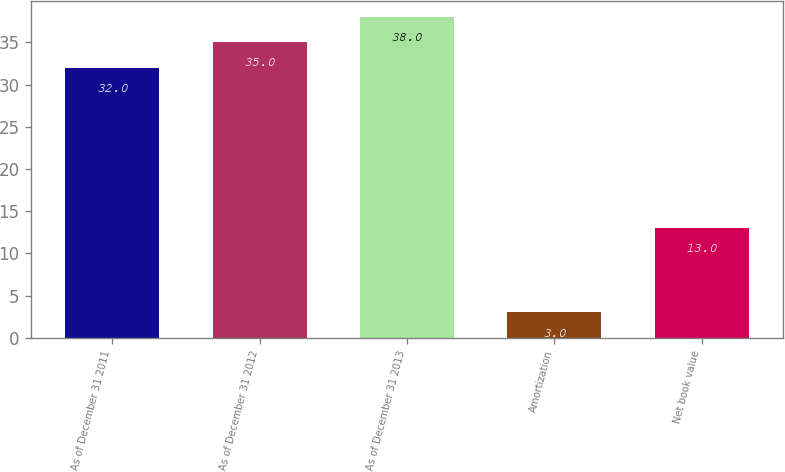Convert chart to OTSL. <chart><loc_0><loc_0><loc_500><loc_500><bar_chart><fcel>As of December 31 2011<fcel>As of December 31 2012<fcel>As of December 31 2013<fcel>Amortization<fcel>Net book value<nl><fcel>32<fcel>35<fcel>38<fcel>3<fcel>13<nl></chart> 